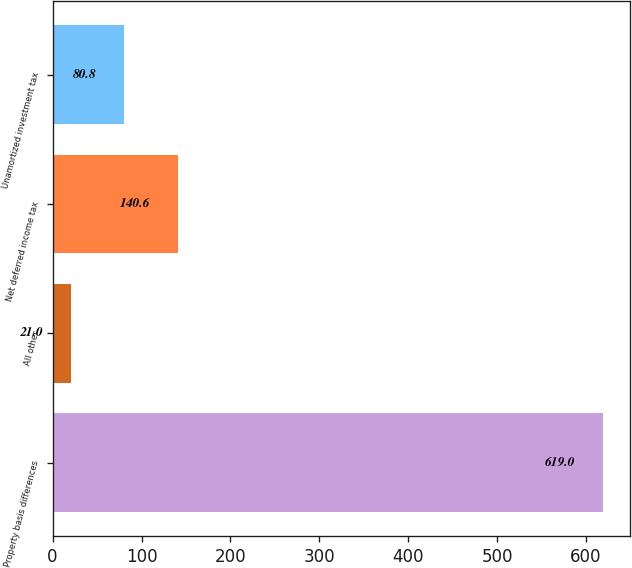<chart> <loc_0><loc_0><loc_500><loc_500><bar_chart><fcel>Property basis differences<fcel>All other<fcel>Net deferred income tax<fcel>Unamortized investment tax<nl><fcel>619<fcel>21<fcel>140.6<fcel>80.8<nl></chart> 